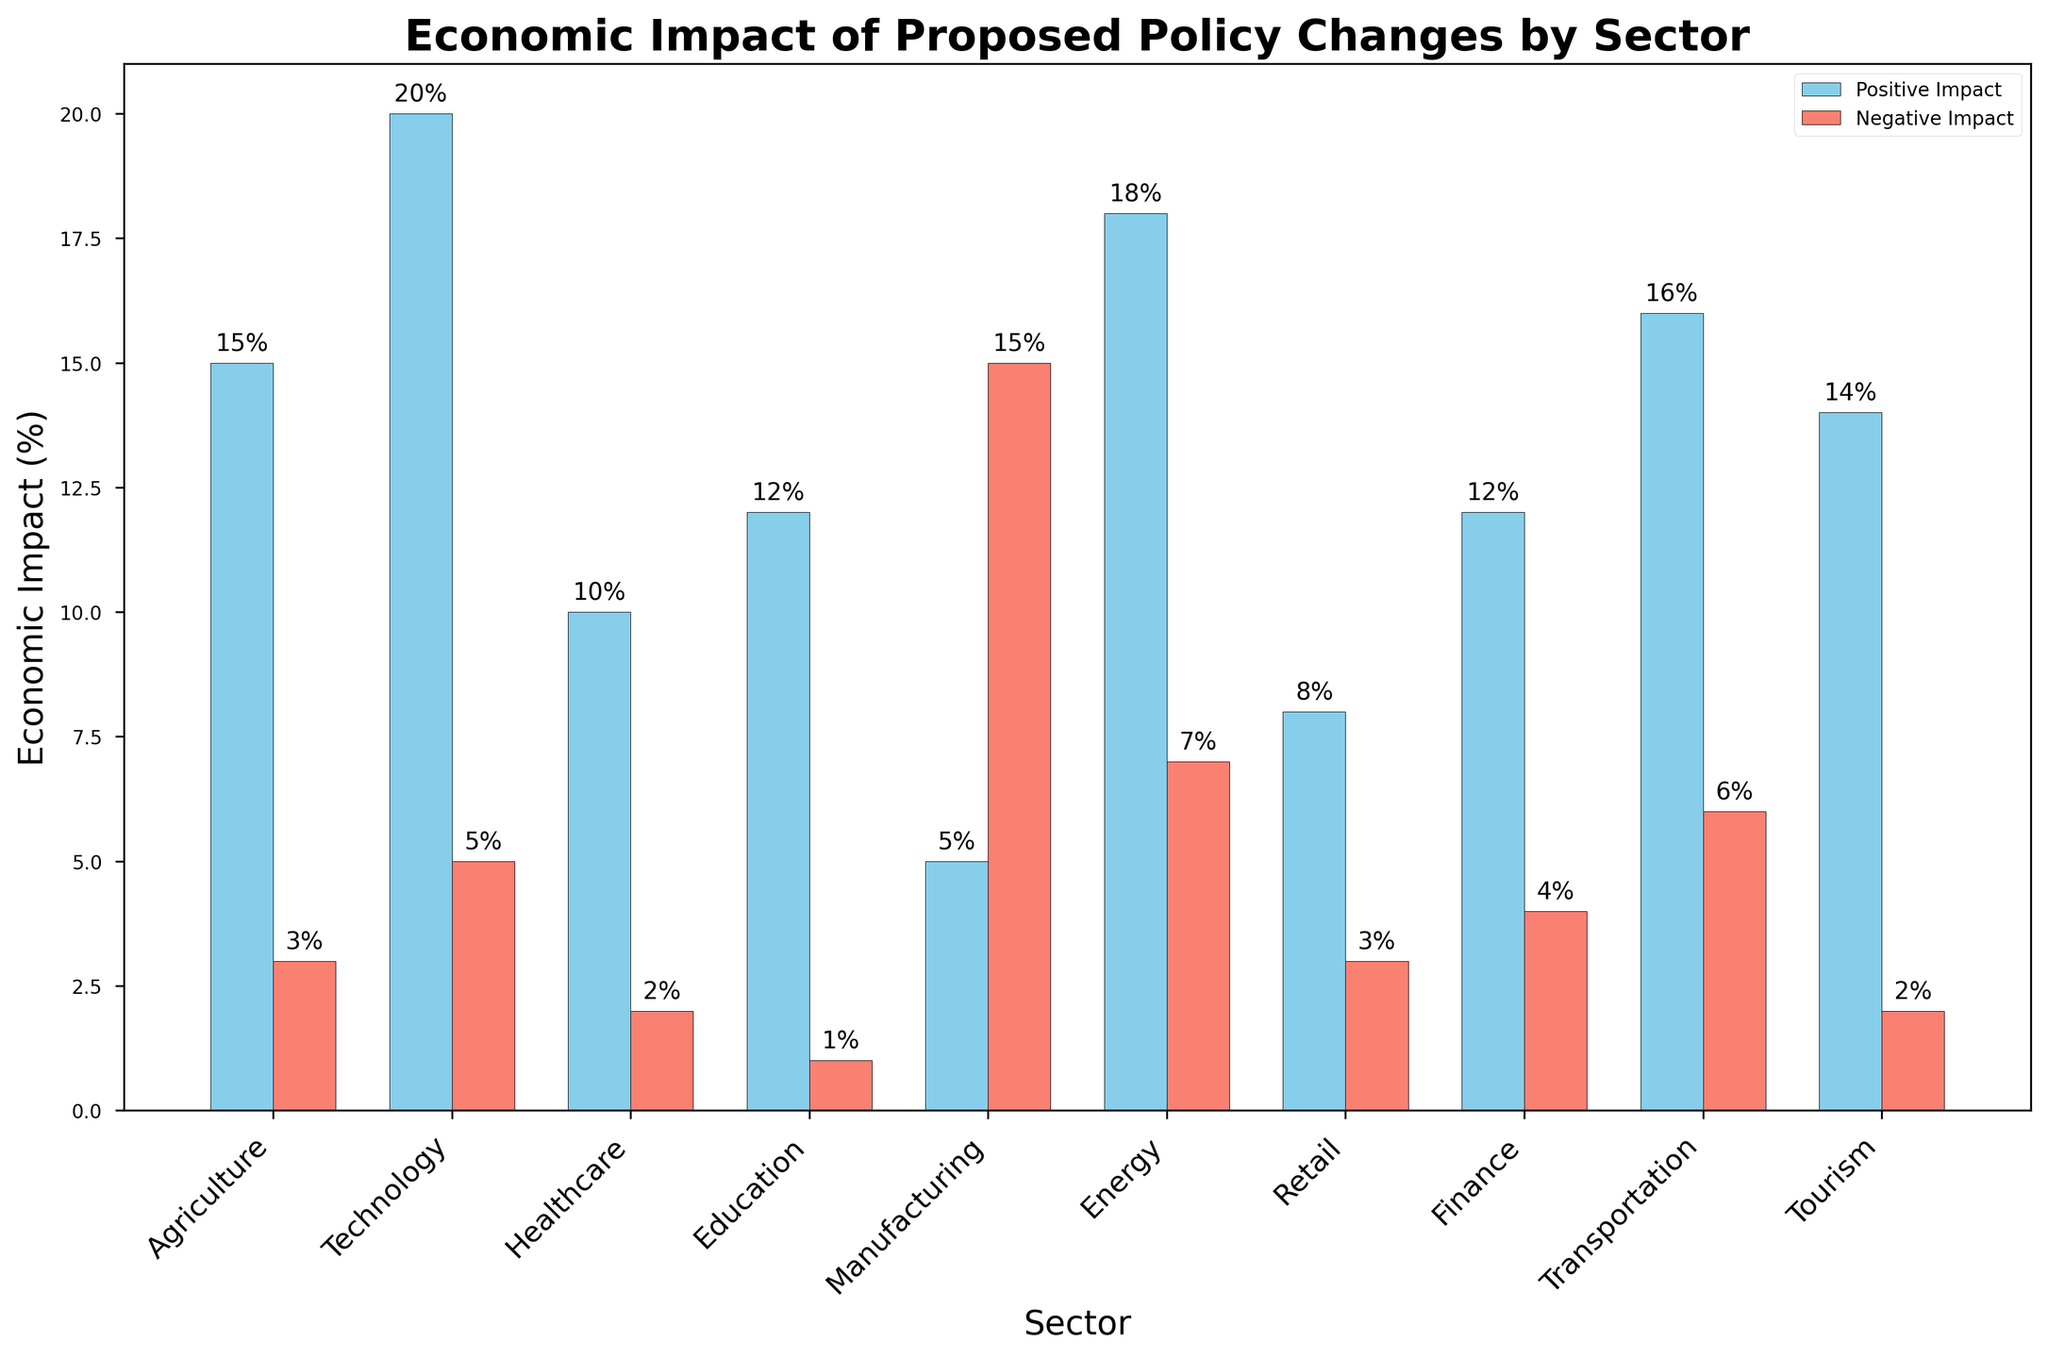Which sector has the highest positive economic impact? Locate the tallest bar in the "Positive Impact" bars, which represents the highest positive economic impact. The Technology sector has the highest positive economic impact at 20%.
Answer: Technology Which sector has the highest negative economic impact? Locate the tallest bar in the "Negative Impact" bars, which represents the highest negative economic impact. The Manufacturing sector has the highest negative economic impact at 15%.
Answer: Manufacturing What is the difference between the positive and negative economic impact in the Energy sector? Find the heights of the "Positive Impact" and "Negative Impact" bars for the Energy sector. The Positive Impact is 18% and the Negative Impact is 7%. Subtract the Negative Impact from the Positive Impact: 18% - 7% = 11%.
Answer: 11% Which sector has the smallest difference between positive and negative economic impact? Calculate the difference between positive and negative impacts for all sectors, then find the smallest difference. The Retail sector has a difference of 8% - 3% = 5%, which is the smallest.
Answer: Retail Among Agriculture, Healthcare, and Education sectors, which has the highest positive economic impact? Compare the heights of the "Positive Impact" bars for Agriculture (15%), Healthcare (10%), and Education (12%). The Agriculture sector has the highest positive economic impact at 15%.
Answer: Agriculture How many sectors have a positive impact of more than 10%? Count the number of bars in the "Positive Impact" bars that display a value greater than 10%. Sectors with positive impacts of more than 10% are Agriculture (15%), Technology (20%), Energy (18%), Transportation (16%), and Tourism (14%). So, there are 5 such sectors.
Answer: 5 Which sector has an equal positive and negative impact? Look for bars in the same sector with equal heights in both "Positive Impact" and "Negative Impact" categories. None of the sectors have equal positive and negative impacts.
Answer: None Which sector shows a greater positive impact than the negative impact by 10% or more? Calculate the difference between positive and negative impacts for each sector and identify those with a difference of 10% or more. The Agriculture (15% - 3% = 12%) and Energy (18% - 7% = 11%) sectors fit this criterion.
Answer: Agriculture, Energy How does the Economic Impact of Regulatory Easing compare with Renewable Investment? Compare the heights of the "Positive Impact" and "Negative Impact" bars for Healthcare (Regulatory Easing) and Energy (Renewable Investment). Positive impact: Healthcare (10%) vs. Energy (18%). Negative impact: Healthcare (2%) vs. Energy (7%).
Answer: Energy has a higher positive and negative impact 